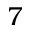<formula> <loc_0><loc_0><loc_500><loc_500>7</formula> 